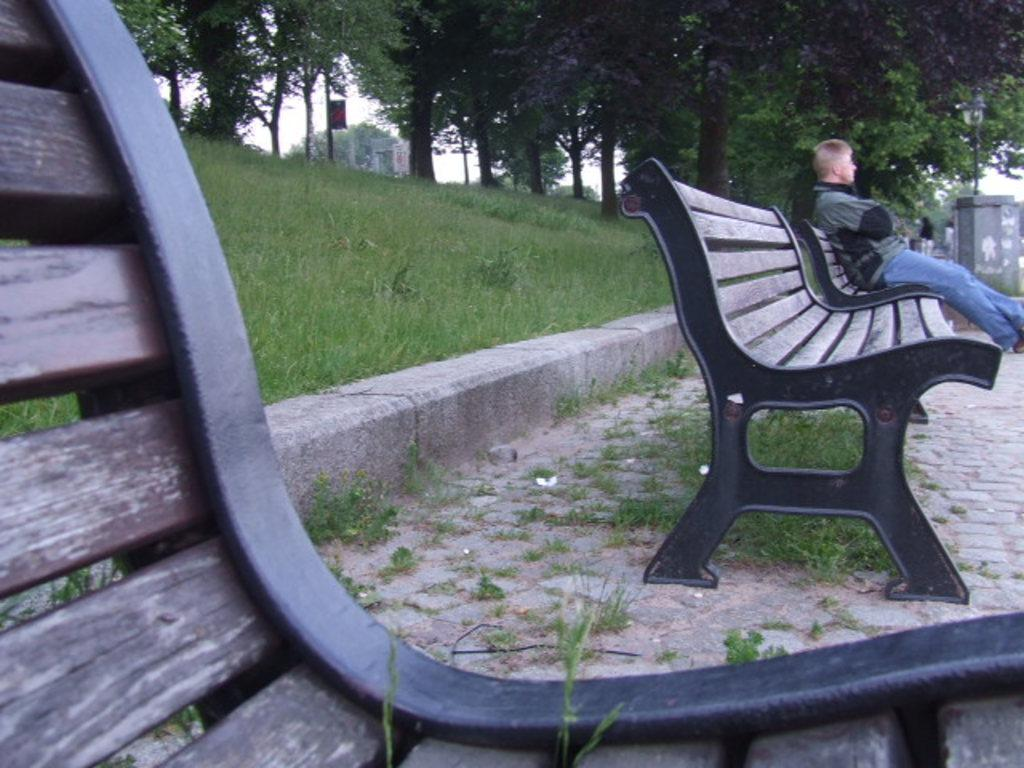What is the man in the image doing? The man is sitting on a bench in the image. What type of vegetation can be seen in the image? There is grass and many trees in the image. What is visible in the background of the image? The sky is visible in the image. What type of crime is being committed in the image? There is no crime being committed in the image; it simply shows a man sitting on a bench in a natural setting. 